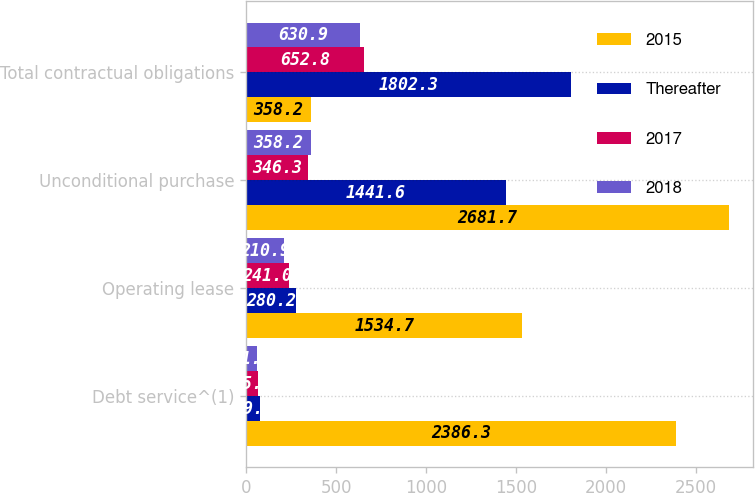<chart> <loc_0><loc_0><loc_500><loc_500><stacked_bar_chart><ecel><fcel>Debt service^(1)<fcel>Operating lease<fcel>Unconditional purchase<fcel>Total contractual obligations<nl><fcel>2015<fcel>2386.3<fcel>1534.7<fcel>2681.7<fcel>358.2<nl><fcel>Thereafter<fcel>79.6<fcel>280.2<fcel>1441.6<fcel>1802.3<nl><fcel>2017<fcel>65.5<fcel>241<fcel>346.3<fcel>652.8<nl><fcel>2018<fcel>61.8<fcel>210.9<fcel>358.2<fcel>630.9<nl></chart> 